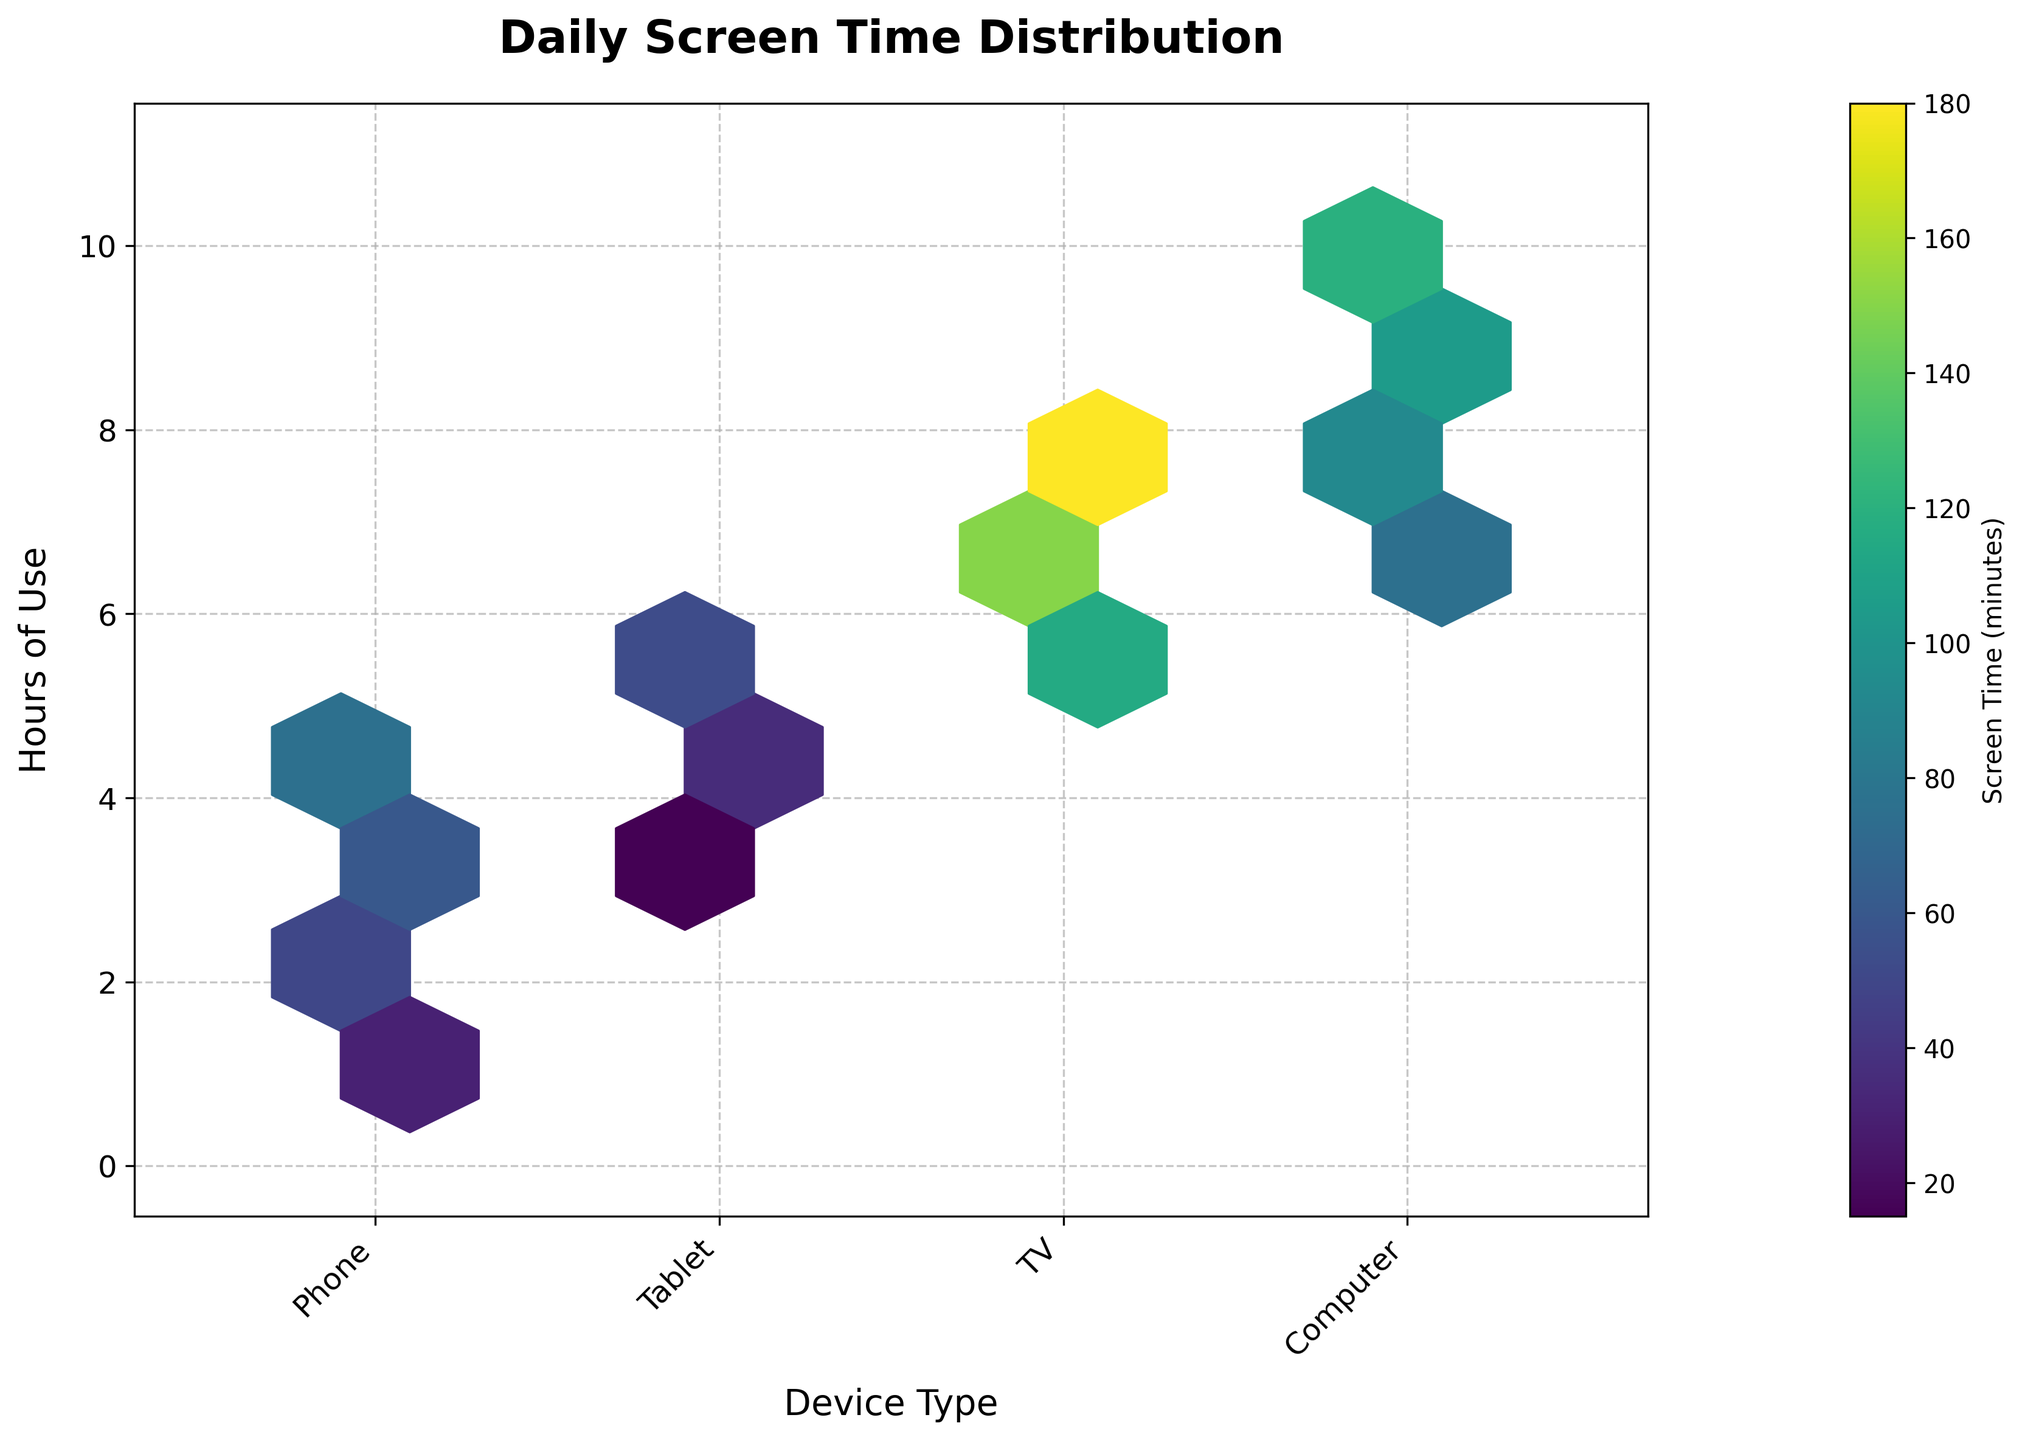What is the title of the Hexbin Plot? The title of the plot is usually written at the top and summarizes the data being visualized. Here, it reads "Daily Screen Time Distribution".
Answer: Daily Screen Time Distribution What device type has the highest screen time usage overall? To determine the device with the highest overall screen time, observe the color intensity and distribution of hexagons associated with each device. The "TV" category has the highest intensity and density of color.
Answer: TV How many hours of phone use are represented in the plot? The y-axis represents hours of use. Count the unique y-values corresponding to 'Phone' from data points which are 1, 2, 3, and 4 hours.
Answer: 4 What is the highest screen time recorded for a 'Computer'? The color indicates the screen time in minutes, and the color bar helps to read this. The hexagon with the highest value for 'Computer' corresponds to around 120 minutes.
Answer: 120 minutes What is the average screen time for 'Tablet'? Sum the 'value' column entries for 'Tablet' device type data points and divide by the number of such points: (30+45+15+60+40)/5=190/5=38.
Answer: 38 Which device has the least screen time usage for 3 hours of use? Locate the hexagons at y=3 and compare color intensities. The 'Tablet' has the lower color intensity compared to others.
Answer: Tablet What range of hours is the y-axis showing? The axis typically marks points at regular intervals. Here, the y-axis ticks range from 0 to 11 hours.
Answer: 0 to 11 Do 'Phone' and 'Tablet' show more than 60 minutes of screen time at any point? Reviewing the color intensity, both 'Phone' and 'Tablet' have hexagon colors indicating more than 60 minutes in certain data points.
Answer: Yes How many devices have screen time recorded for 8 hours of use? Data at y=8 is represented by 'TV' and 'Computer'.
Answer: 2 devices Which device type shows more consistent screen time across various hours? Consistency can be inferred from the distribution of hexagonal bins with similar color intensity. 'TV' shows a broad spread with relatively high consistent usage.
Answer: TV 